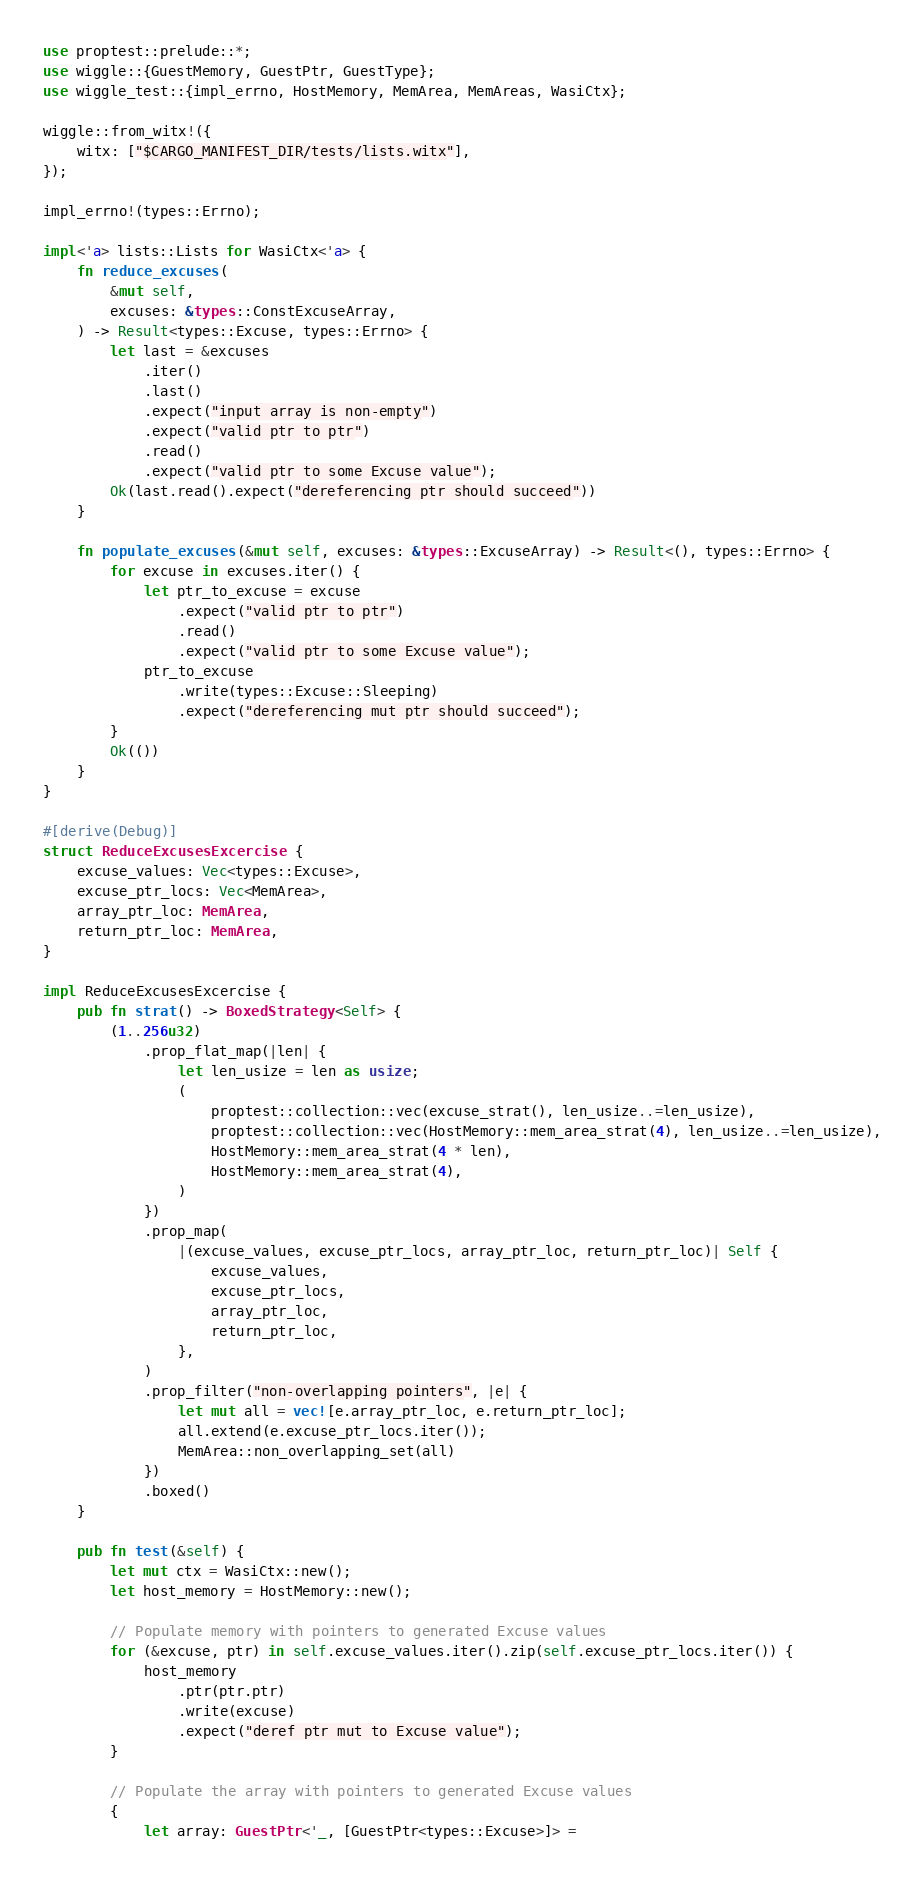Convert code to text. <code><loc_0><loc_0><loc_500><loc_500><_Rust_>use proptest::prelude::*;
use wiggle::{GuestMemory, GuestPtr, GuestType};
use wiggle_test::{impl_errno, HostMemory, MemArea, MemAreas, WasiCtx};

wiggle::from_witx!({
    witx: ["$CARGO_MANIFEST_DIR/tests/lists.witx"],
});

impl_errno!(types::Errno);

impl<'a> lists::Lists for WasiCtx<'a> {
    fn reduce_excuses(
        &mut self,
        excuses: &types::ConstExcuseArray,
    ) -> Result<types::Excuse, types::Errno> {
        let last = &excuses
            .iter()
            .last()
            .expect("input array is non-empty")
            .expect("valid ptr to ptr")
            .read()
            .expect("valid ptr to some Excuse value");
        Ok(last.read().expect("dereferencing ptr should succeed"))
    }

    fn populate_excuses(&mut self, excuses: &types::ExcuseArray) -> Result<(), types::Errno> {
        for excuse in excuses.iter() {
            let ptr_to_excuse = excuse
                .expect("valid ptr to ptr")
                .read()
                .expect("valid ptr to some Excuse value");
            ptr_to_excuse
                .write(types::Excuse::Sleeping)
                .expect("dereferencing mut ptr should succeed");
        }
        Ok(())
    }
}

#[derive(Debug)]
struct ReduceExcusesExcercise {
    excuse_values: Vec<types::Excuse>,
    excuse_ptr_locs: Vec<MemArea>,
    array_ptr_loc: MemArea,
    return_ptr_loc: MemArea,
}

impl ReduceExcusesExcercise {
    pub fn strat() -> BoxedStrategy<Self> {
        (1..256u32)
            .prop_flat_map(|len| {
                let len_usize = len as usize;
                (
                    proptest::collection::vec(excuse_strat(), len_usize..=len_usize),
                    proptest::collection::vec(HostMemory::mem_area_strat(4), len_usize..=len_usize),
                    HostMemory::mem_area_strat(4 * len),
                    HostMemory::mem_area_strat(4),
                )
            })
            .prop_map(
                |(excuse_values, excuse_ptr_locs, array_ptr_loc, return_ptr_loc)| Self {
                    excuse_values,
                    excuse_ptr_locs,
                    array_ptr_loc,
                    return_ptr_loc,
                },
            )
            .prop_filter("non-overlapping pointers", |e| {
                let mut all = vec![e.array_ptr_loc, e.return_ptr_loc];
                all.extend(e.excuse_ptr_locs.iter());
                MemArea::non_overlapping_set(all)
            })
            .boxed()
    }

    pub fn test(&self) {
        let mut ctx = WasiCtx::new();
        let host_memory = HostMemory::new();

        // Populate memory with pointers to generated Excuse values
        for (&excuse, ptr) in self.excuse_values.iter().zip(self.excuse_ptr_locs.iter()) {
            host_memory
                .ptr(ptr.ptr)
                .write(excuse)
                .expect("deref ptr mut to Excuse value");
        }

        // Populate the array with pointers to generated Excuse values
        {
            let array: GuestPtr<'_, [GuestPtr<types::Excuse>]> =</code> 